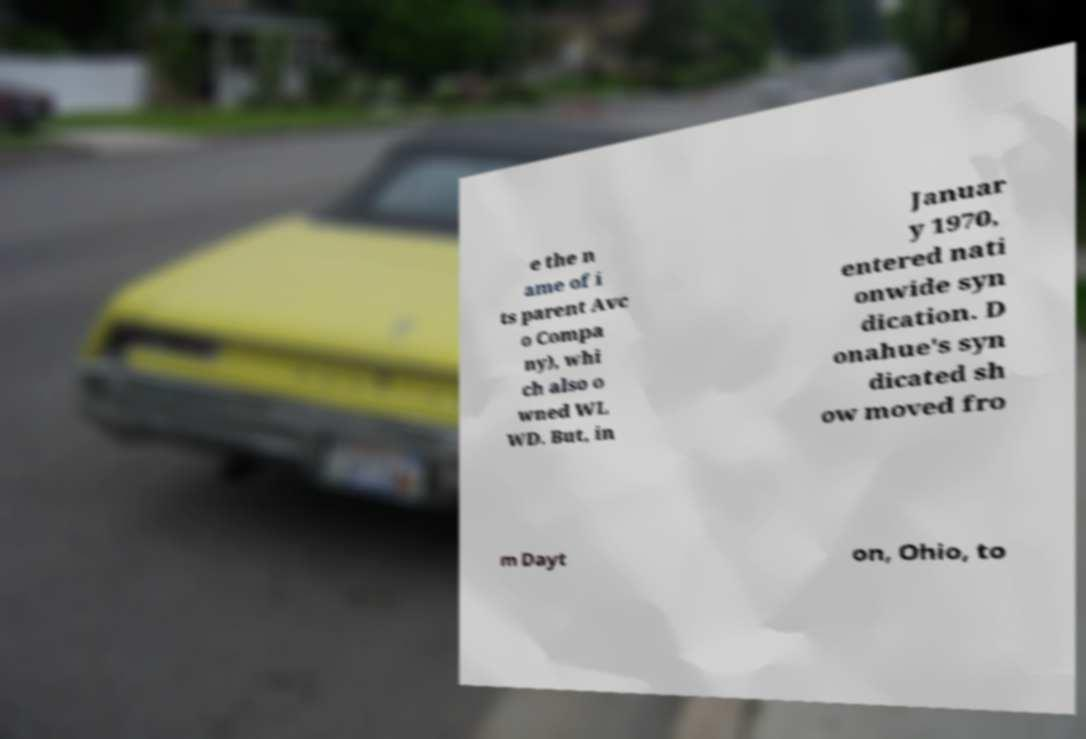There's text embedded in this image that I need extracted. Can you transcribe it verbatim? e the n ame of i ts parent Avc o Compa ny), whi ch also o wned WL WD. But, in Januar y 1970, entered nati onwide syn dication. D onahue's syn dicated sh ow moved fro m Dayt on, Ohio, to 